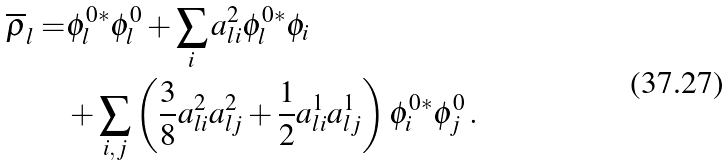<formula> <loc_0><loc_0><loc_500><loc_500>\overline { \rho } _ { l } = & \phi ^ { 0 * } _ { l } \phi ^ { 0 } _ { l } + \sum _ { i } a ^ { 2 } _ { l i } \phi ^ { 0 * } _ { l } \phi _ { i } \\ & + \sum _ { i , j } \left ( \frac { 3 } { 8 } a ^ { 2 } _ { l i } a ^ { 2 } _ { l j } + \frac { 1 } { 2 } a ^ { 1 } _ { l i } a ^ { 1 } _ { l j } \right ) \phi ^ { 0 * } _ { i } \phi ^ { 0 } _ { j } \, .</formula> 